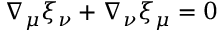Convert formula to latex. <formula><loc_0><loc_0><loc_500><loc_500>\nabla _ { \mu } \xi _ { \nu } + \nabla _ { \nu } \xi _ { \mu } = 0</formula> 